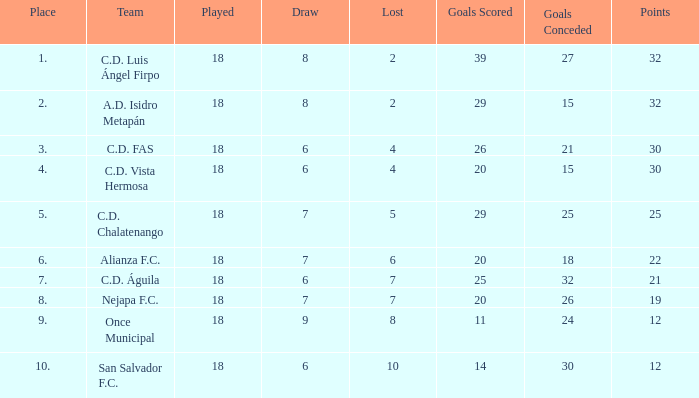Help me parse the entirety of this table. {'header': ['Place', 'Team', 'Played', 'Draw', 'Lost', 'Goals Scored', 'Goals Conceded', 'Points'], 'rows': [['1.', 'C.D. Luis Ángel Firpo', '18', '8', '2', '39', '27', '32'], ['2.', 'A.D. Isidro Metapán', '18', '8', '2', '29', '15', '32'], ['3.', 'C.D. FAS', '18', '6', '4', '26', '21', '30'], ['4.', 'C.D. Vista Hermosa', '18', '6', '4', '20', '15', '30'], ['5.', 'C.D. Chalatenango', '18', '7', '5', '29', '25', '25'], ['6.', 'Alianza F.C.', '18', '7', '6', '20', '18', '22'], ['7.', 'C.D. Águila', '18', '6', '7', '25', '32', '21'], ['8.', 'Nejapa F.C.', '18', '7', '7', '20', '26', '19'], ['9.', 'Once Municipal', '18', '9', '8', '11', '24', '12'], ['10.', 'San Salvador F.C.', '18', '6', '10', '14', '30', '12']]} What team with a goals conceded smaller than 25, and a place smaller than 3? A.D. Isidro Metapán. 